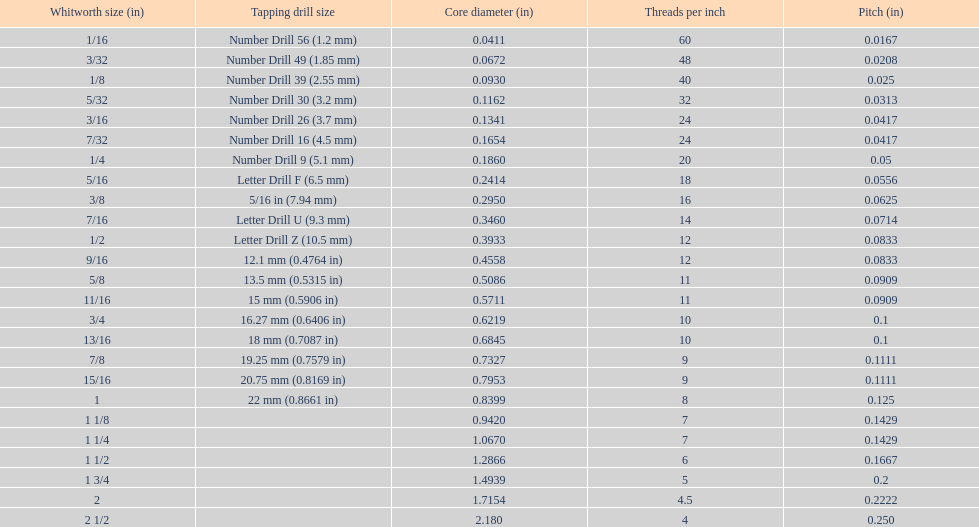What is the next whitworth size (in) below 1/8? 5/32. 